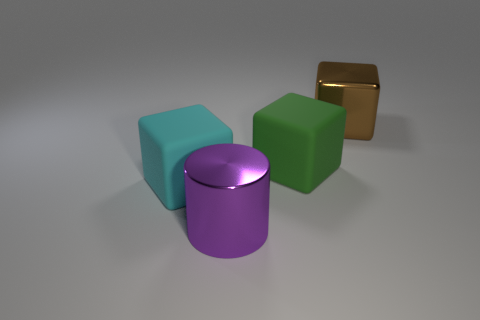Subtract all cyan matte cubes. How many cubes are left? 2 Add 2 cylinders. How many objects exist? 6 Subtract 0 purple spheres. How many objects are left? 4 Subtract all blocks. How many objects are left? 1 Subtract all big cylinders. Subtract all purple cylinders. How many objects are left? 2 Add 1 green rubber objects. How many green rubber objects are left? 2 Add 4 big metallic cubes. How many big metallic cubes exist? 5 